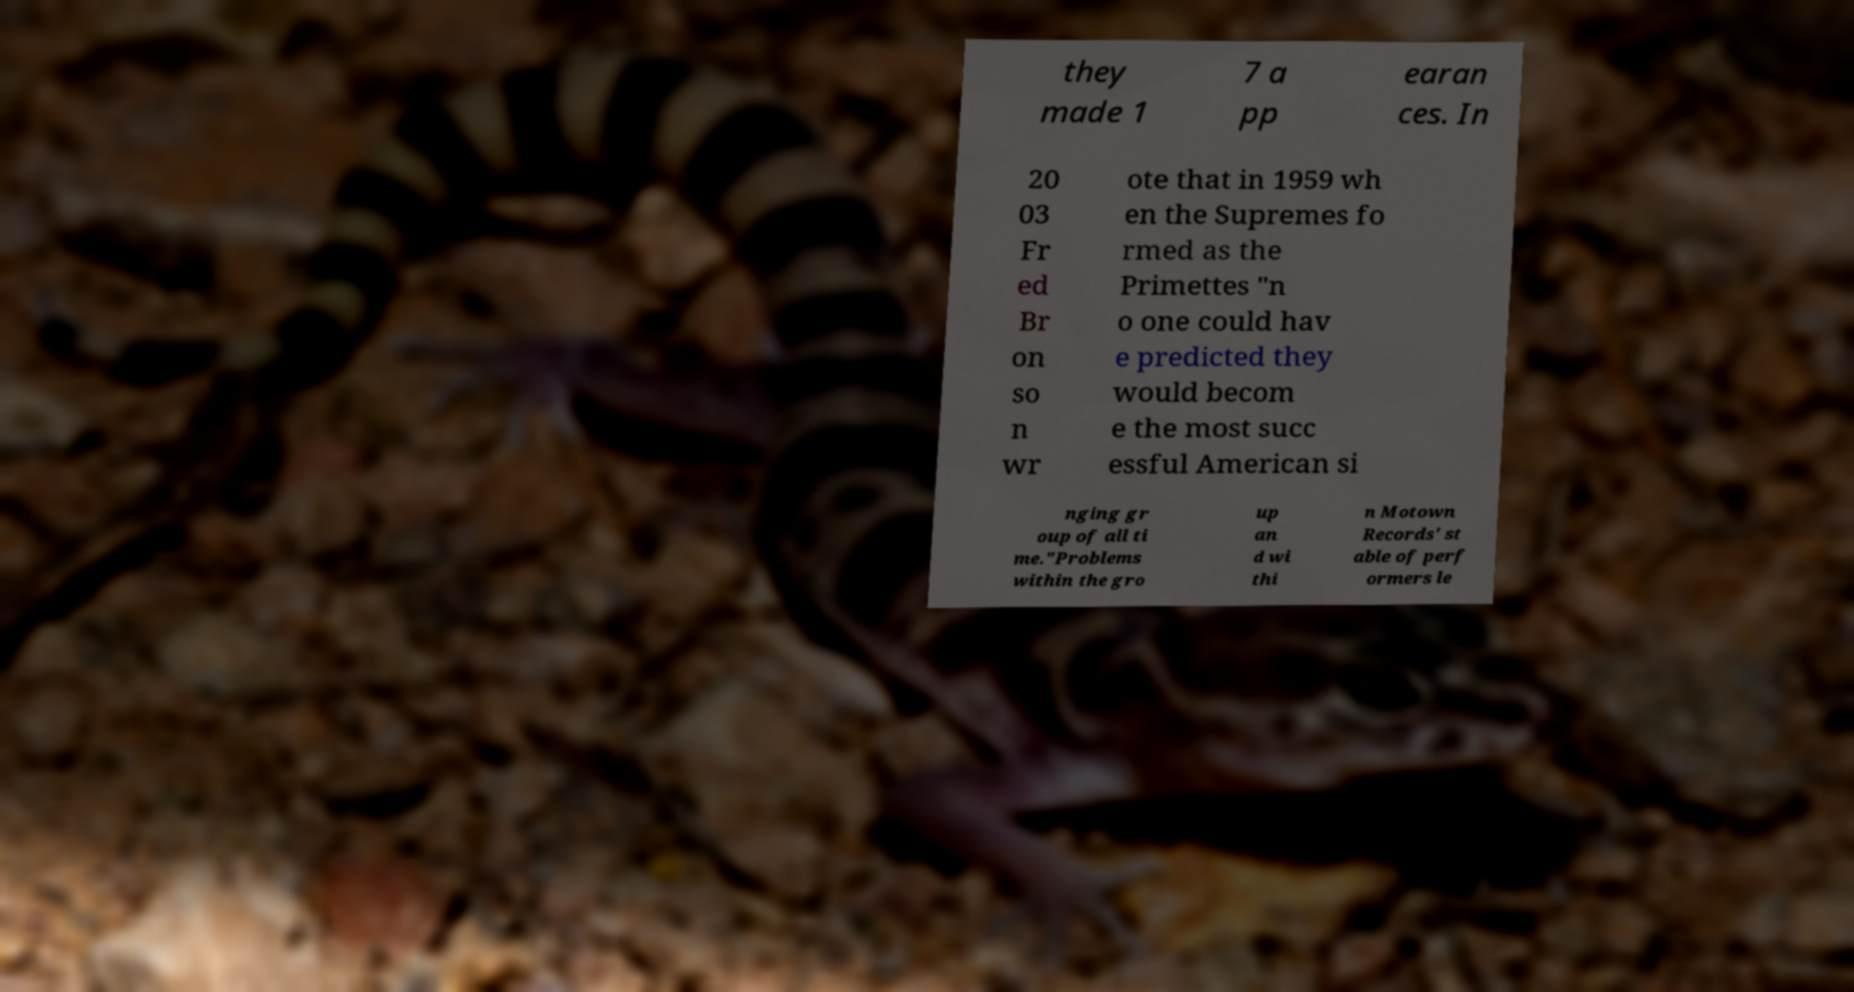I need the written content from this picture converted into text. Can you do that? they made 1 7 a pp earan ces. In 20 03 Fr ed Br on so n wr ote that in 1959 wh en the Supremes fo rmed as the Primettes "n o one could hav e predicted they would becom e the most succ essful American si nging gr oup of all ti me."Problems within the gro up an d wi thi n Motown Records' st able of perf ormers le 